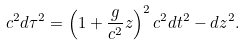<formula> <loc_0><loc_0><loc_500><loc_500>c ^ { 2 } d \tau ^ { 2 } = \left ( 1 + \frac { g } { c ^ { 2 } } z \right ) ^ { 2 } c ^ { 2 } d t ^ { 2 } - d z ^ { 2 } .</formula> 